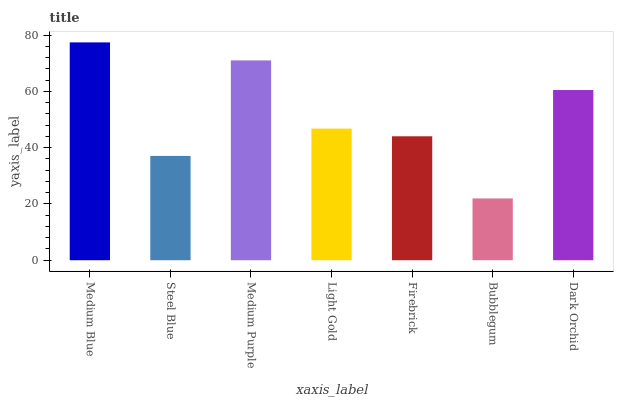Is Bubblegum the minimum?
Answer yes or no. Yes. Is Medium Blue the maximum?
Answer yes or no. Yes. Is Steel Blue the minimum?
Answer yes or no. No. Is Steel Blue the maximum?
Answer yes or no. No. Is Medium Blue greater than Steel Blue?
Answer yes or no. Yes. Is Steel Blue less than Medium Blue?
Answer yes or no. Yes. Is Steel Blue greater than Medium Blue?
Answer yes or no. No. Is Medium Blue less than Steel Blue?
Answer yes or no. No. Is Light Gold the high median?
Answer yes or no. Yes. Is Light Gold the low median?
Answer yes or no. Yes. Is Medium Purple the high median?
Answer yes or no. No. Is Steel Blue the low median?
Answer yes or no. No. 